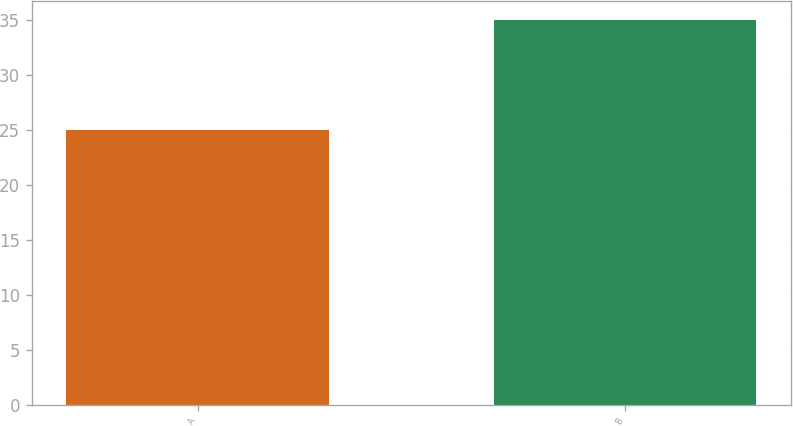Convert chart. <chart><loc_0><loc_0><loc_500><loc_500><bar_chart><fcel>A<fcel>B<nl><fcel>25<fcel>35<nl></chart> 